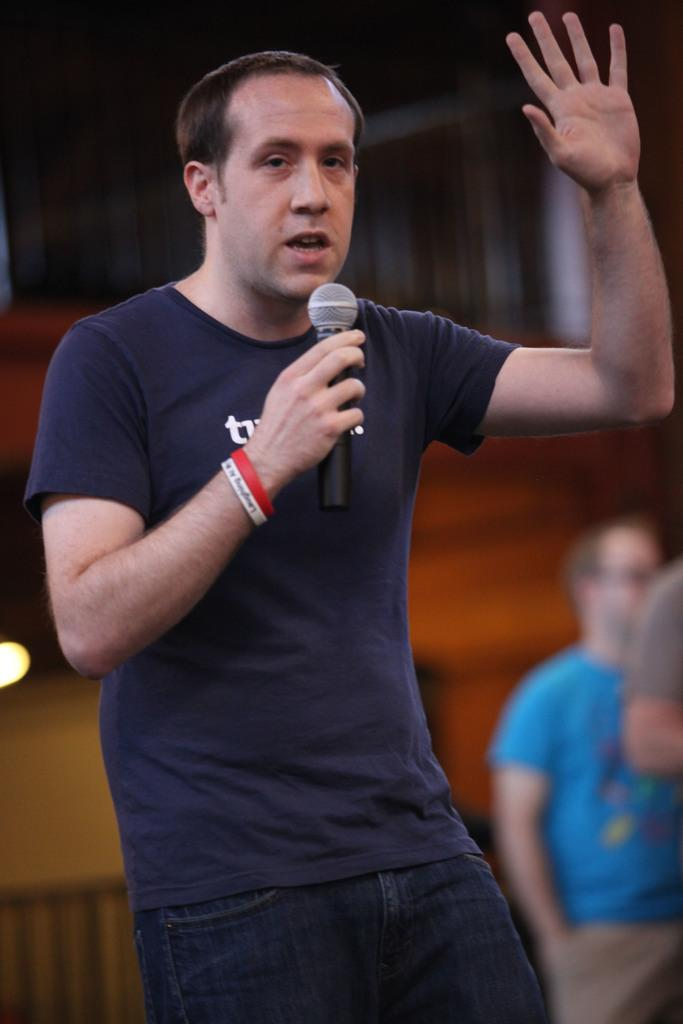What is the main subject of the image? The main subject of the image is a man standing in the center. What is the man holding in his hand? The man is holding a mic in his hand. Are there any other people in the image besides the man with the mic? Yes, there are two persons standing on the right side of the image. What type of flower is the father holding in the image? There is no father or flower present in the image; it features a man holding a mic. Can you describe the squirrel sitting on the man's shoulder in the image? There is no squirrel present in the image; it only shows a man holding a mic and two other persons standing nearby. 